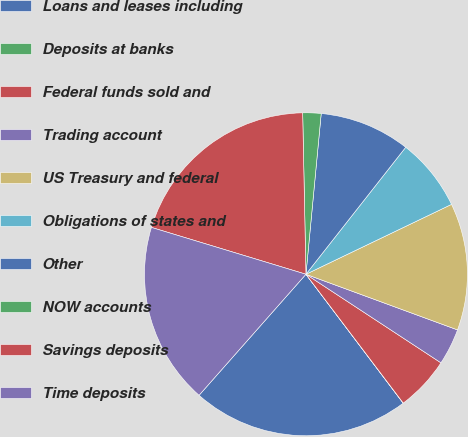<chart> <loc_0><loc_0><loc_500><loc_500><pie_chart><fcel>Loans and leases including<fcel>Deposits at banks<fcel>Federal funds sold and<fcel>Trading account<fcel>US Treasury and federal<fcel>Obligations of states and<fcel>Other<fcel>NOW accounts<fcel>Savings deposits<fcel>Time deposits<nl><fcel>21.8%<fcel>0.01%<fcel>5.46%<fcel>3.64%<fcel>12.72%<fcel>7.28%<fcel>9.09%<fcel>1.83%<fcel>19.99%<fcel>18.17%<nl></chart> 